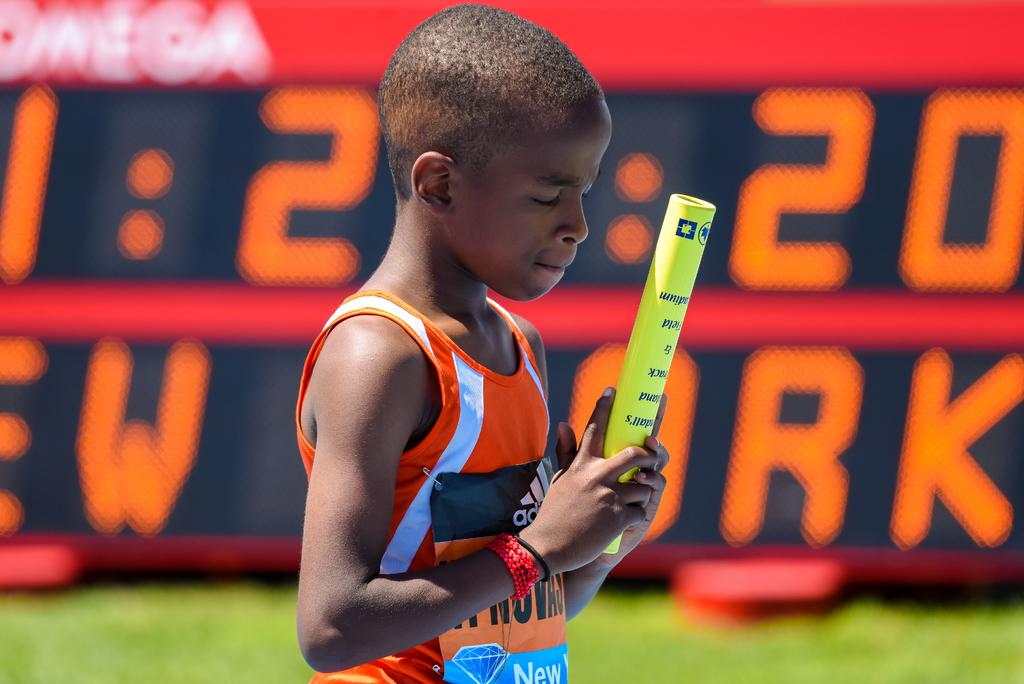What is the main subject in the center of the image? There is a boy in the center of the image. What is the boy holding in his hand? The boy is holding an object in his hand. What can be seen in the background of the image? There is a screen in the background of the image. What is displayed on the screen? The screen has some text on it. What type of cough medicine is the boy using in the image? There is no cough medicine or any indication of a cough in the image. The boy is holding an object, but its nature is not specified. 